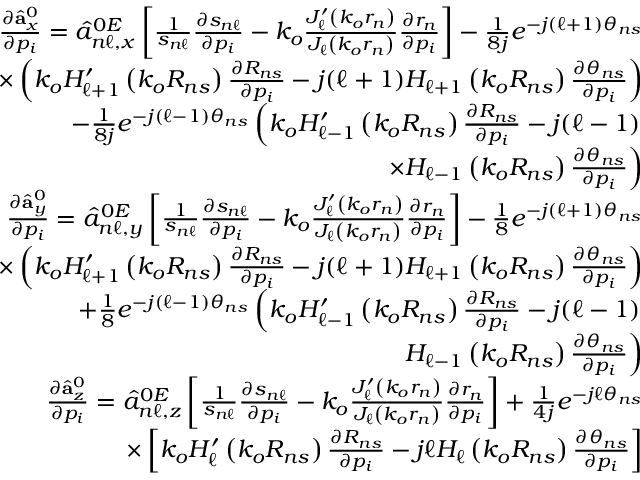<formula> <loc_0><loc_0><loc_500><loc_500>\begin{array} { r l r } & { \frac { \partial \hat { a } _ { x } ^ { 0 } } { \partial p _ { i } } = \hat { a } _ { n \ell , x } ^ { 0 E } \left [ \frac { 1 } { s _ { n \ell } } \frac { \partial s _ { n \ell } } { \partial p _ { i } } - k _ { o } \frac { J _ { \ell } ^ { \prime } \left ( k _ { o } r _ { n } \right ) } { J _ { \ell } \left ( k _ { o } r _ { n } \right ) } \frac { \partial r _ { n } } { \partial p _ { i } } \right ] - \frac { 1 } { 8 j } e ^ { - j ( \ell + 1 ) \theta _ { n s } } } \\ & { \times \left ( k _ { o } H _ { \ell + 1 } ^ { \prime } \left ( k _ { o } R _ { n s } \right ) \frac { \partial R _ { n s } } { \partial p _ { i } } - j ( \ell + 1 ) H _ { \ell + 1 } \left ( k _ { o } R _ { n s } \right ) \frac { \partial \theta _ { n s } } { \partial p _ { i } } \right ) } \\ & { - \frac { 1 } { 8 j } e ^ { - j ( \ell - 1 ) \theta _ { n s } } \left ( k _ { o } H _ { \ell - 1 } ^ { \prime } \left ( k _ { o } R _ { n s } \right ) \frac { \partial R _ { n s } } { \partial p _ { i } } - j ( \ell - 1 ) } \\ & { \times H _ { \ell - 1 } \left ( k _ { o } R _ { n s } \right ) \frac { \partial \theta _ { n s } } { \partial p _ { i } } \right ) } \\ & { \frac { \partial \hat { a } _ { y } ^ { 0 } } { \partial p _ { i } } = \hat { a } _ { n \ell , y } ^ { 0 E } \left [ \frac { 1 } { s _ { n \ell } } \frac { \partial s _ { n \ell } } { \partial p _ { i } } - k _ { o } \frac { J _ { \ell } ^ { \prime } \left ( k _ { o } r _ { n } \right ) } { J _ { \ell } \left ( k _ { o } r _ { n } \right ) } \frac { \partial r _ { n } } { \partial p _ { i } } \right ] - \frac { 1 } { 8 } e ^ { - j ( \ell + 1 ) \theta _ { n s } } } \\ & { \times \left ( k _ { o } H _ { \ell + 1 } ^ { \prime } \left ( k _ { o } R _ { n s } \right ) \frac { \partial R _ { n s } } { \partial p _ { i } } - j ( \ell + 1 ) H _ { \ell + 1 } \left ( k _ { o } R _ { n s } \right ) \frac { \partial \theta _ { n s } } { \partial p _ { i } } \right ) } \\ & { + \frac { 1 } { 8 } e ^ { - j ( \ell - 1 ) \theta _ { n s } } \left ( k _ { o } H _ { \ell - 1 } ^ { \prime } \left ( k _ { o } R _ { n s } \right ) \frac { \partial R _ { n s } } { \partial p _ { i } } - j ( \ell - 1 ) } \\ & { H _ { \ell - 1 } \left ( k _ { o } R _ { n s } \right ) \frac { \partial \theta _ { n s } } { \partial p _ { i } } \right ) } \\ & { \frac { \partial \hat { a } _ { z } ^ { 0 } } { \partial p _ { i } } = \hat { a } _ { n \ell , z } ^ { 0 E } \left [ \frac { 1 } { s _ { n \ell } } \frac { \partial s _ { n \ell } } { \partial p _ { i } } - k _ { o } \frac { J _ { \ell } ^ { \prime } \left ( k _ { o } r _ { n } \right ) } { J _ { \ell } \left ( k _ { o } r _ { n } \right ) } \frac { \partial r _ { n } } { \partial p _ { i } } \right ] + \frac { 1 } { 4 j } e ^ { - j \ell \theta _ { n s } } } \\ & { \times \left [ k _ { o } H _ { \ell } ^ { \prime } \left ( k _ { o } R _ { n s } \right ) \frac { \partial R _ { n s } } { \partial p _ { i } } - j \ell H _ { \ell } \left ( k _ { o } R _ { n s } \right ) \frac { \partial \theta _ { n s } } { \partial p _ { i } } \right ] } \end{array}</formula> 